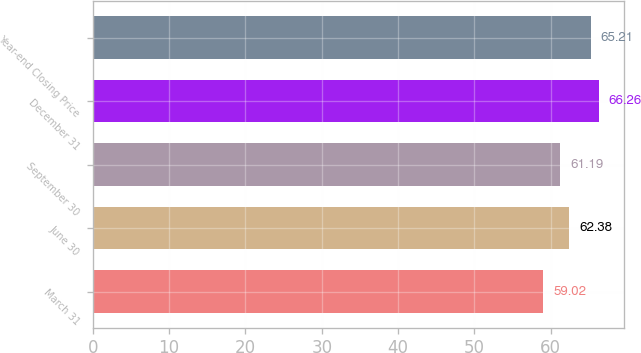<chart> <loc_0><loc_0><loc_500><loc_500><bar_chart><fcel>March 31<fcel>June 30<fcel>September 30<fcel>December 31<fcel>Year-end Closing Price<nl><fcel>59.02<fcel>62.38<fcel>61.19<fcel>66.26<fcel>65.21<nl></chart> 